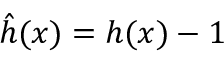Convert formula to latex. <formula><loc_0><loc_0><loc_500><loc_500>\hat { h } ( x ) = h ( x ) - 1</formula> 